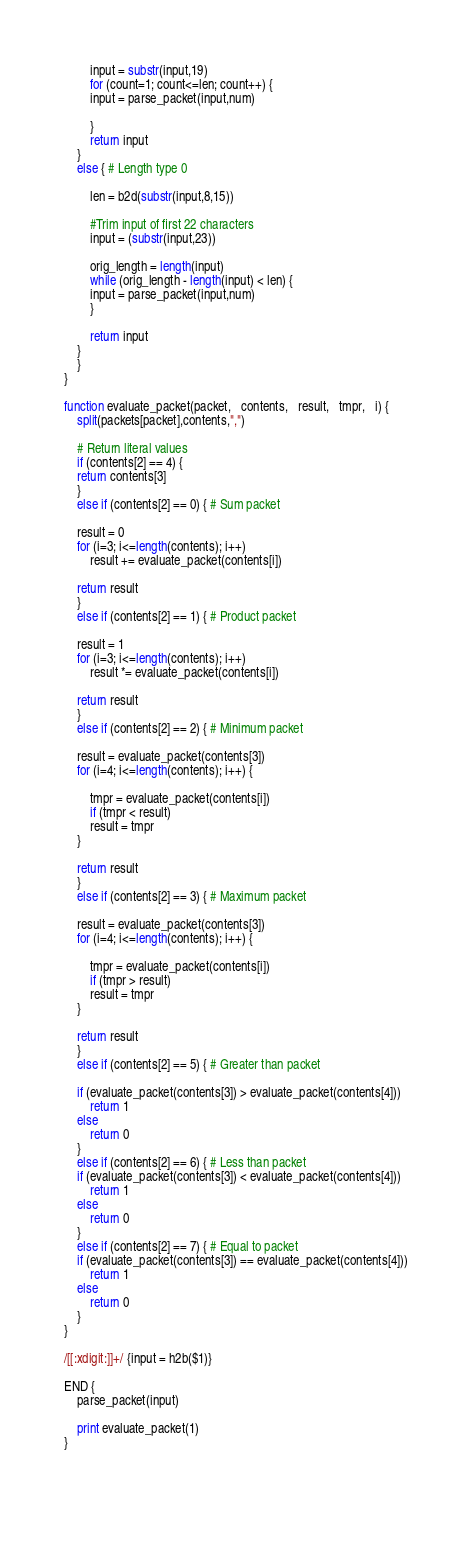<code> <loc_0><loc_0><loc_500><loc_500><_Awk_>	    input = substr(input,19)
	    for (count=1; count<=len; count++) {
		input = parse_packet(input,num)

	    }
	    return input
	}
	else { # Length type 0

	    len = b2d(substr(input,8,15))

	    #Trim input of first 22 characters
	    input = (substr(input,23))

	    orig_length = length(input)
	    while (orig_length - length(input) < len) {
		input = parse_packet(input,num)
	    }
	    
	    return input
	}
    }
}

function evaluate_packet(packet,   contents,   result,   tmpr,   i) {
    split(packets[packet],contents,",")

    # Return literal values
    if (contents[2] == 4) {
	return contents[3]
    }
    else if (contents[2] == 0) { # Sum packet

	result = 0
	for (i=3; i<=length(contents); i++)
	    result += evaluate_packet(contents[i])

	return result
    }
    else if (contents[2] == 1) { # Product packet

	result = 1
	for (i=3; i<=length(contents); i++)
	    result *= evaluate_packet(contents[i])

	return result
    }
    else if (contents[2] == 2) { # Minimum packet

	result = evaluate_packet(contents[3])
	for (i=4; i<=length(contents); i++) {

	    tmpr = evaluate_packet(contents[i])
	    if (tmpr < result)
		result = tmpr
	}

	return result
    }
    else if (contents[2] == 3) { # Maximum packet
	
	result = evaluate_packet(contents[3])
	for (i=4; i<=length(contents); i++) {

	    tmpr = evaluate_packet(contents[i])
	    if (tmpr > result)
		result = tmpr
	}

	return result
    }
    else if (contents[2] == 5) { # Greater than packet
	
	if (evaluate_packet(contents[3]) > evaluate_packet(contents[4]))
	    return 1
	else
	    return 0
    }
    else if (contents[2] == 6) { # Less than packet
	if (evaluate_packet(contents[3]) < evaluate_packet(contents[4]))
	    return 1
	else
	    return 0
    }
    else if (contents[2] == 7) { # Equal to packet
	if (evaluate_packet(contents[3]) == evaluate_packet(contents[4]))
	    return 1
	else
	    return 0
    }
}

/[[:xdigit:]]+/ {input = h2b($1)}

END {
    parse_packet(input)

    print evaluate_packet(1)
}

	     
	     
</code> 